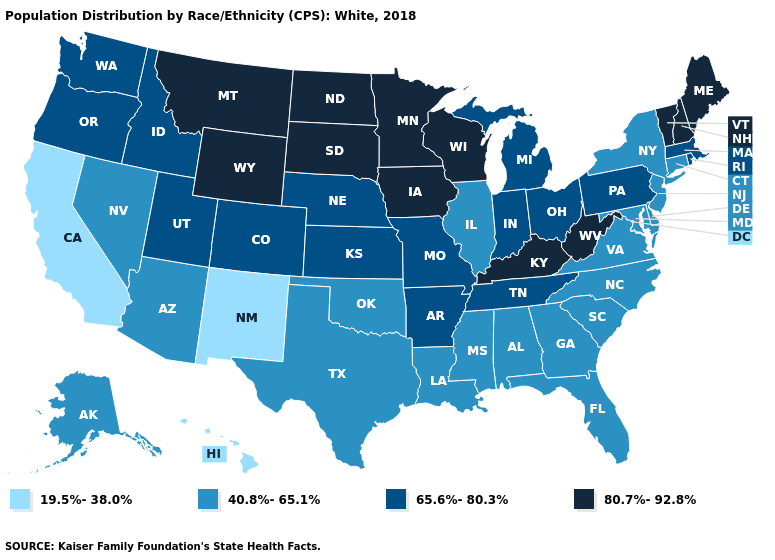What is the value of Missouri?
Give a very brief answer. 65.6%-80.3%. Does Montana have the highest value in the USA?
Be succinct. Yes. Does Illinois have the same value as Louisiana?
Keep it brief. Yes. Does Mississippi have a higher value than Hawaii?
Be succinct. Yes. What is the lowest value in the USA?
Answer briefly. 19.5%-38.0%. Name the states that have a value in the range 65.6%-80.3%?
Keep it brief. Arkansas, Colorado, Idaho, Indiana, Kansas, Massachusetts, Michigan, Missouri, Nebraska, Ohio, Oregon, Pennsylvania, Rhode Island, Tennessee, Utah, Washington. What is the value of Virginia?
Concise answer only. 40.8%-65.1%. Does the map have missing data?
Write a very short answer. No. What is the value of Minnesota?
Write a very short answer. 80.7%-92.8%. What is the value of Colorado?
Be succinct. 65.6%-80.3%. What is the value of Minnesota?
Give a very brief answer. 80.7%-92.8%. Name the states that have a value in the range 19.5%-38.0%?
Short answer required. California, Hawaii, New Mexico. What is the highest value in the Northeast ?
Answer briefly. 80.7%-92.8%. Which states have the lowest value in the USA?
Keep it brief. California, Hawaii, New Mexico. Which states hav the highest value in the Northeast?
Concise answer only. Maine, New Hampshire, Vermont. 